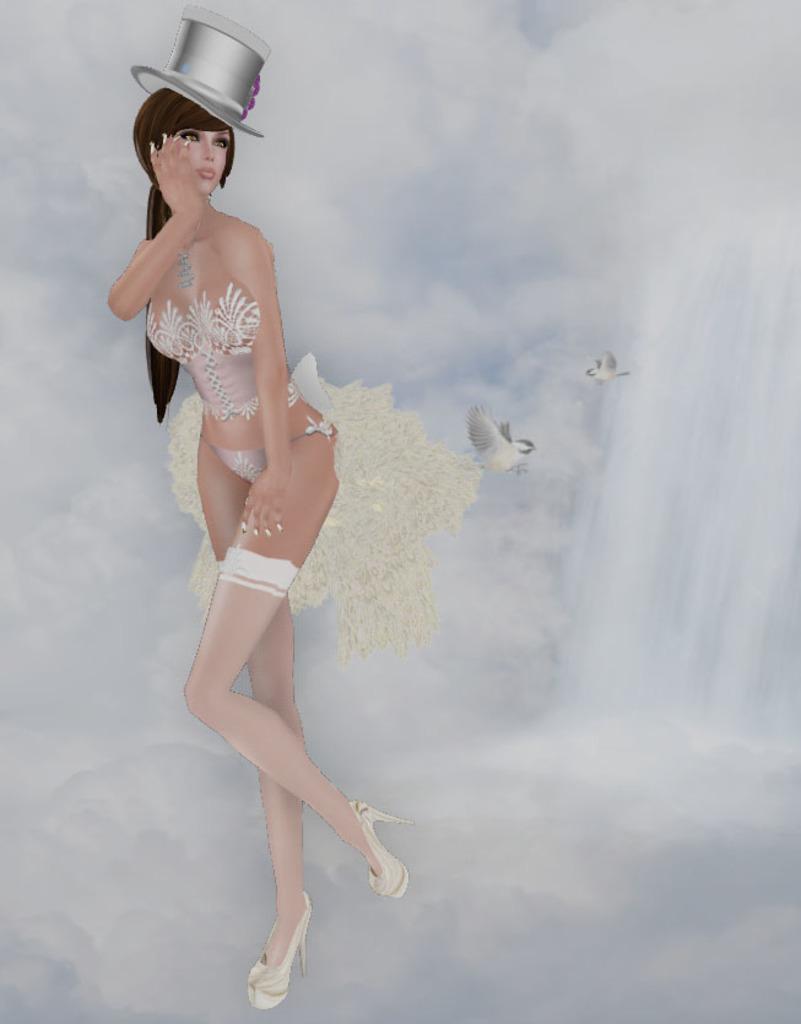In one or two sentences, can you explain what this image depicts? This image looks like a depiction in which I can see birds, woman and the sky. 